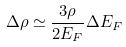Convert formula to latex. <formula><loc_0><loc_0><loc_500><loc_500>\Delta \rho \simeq \frac { 3 \rho } { 2 E _ { F } } \Delta E _ { F }</formula> 